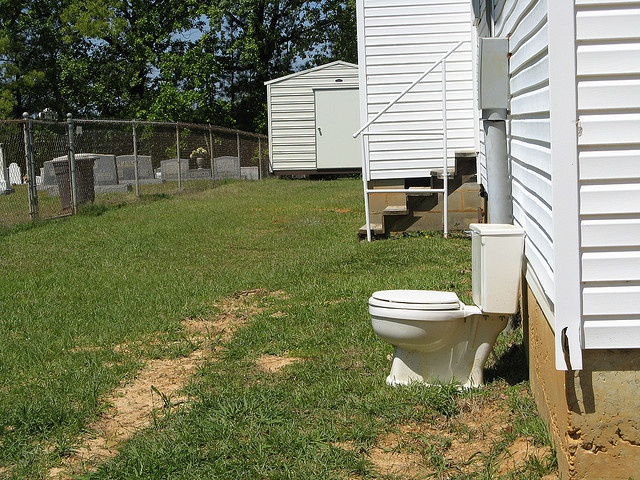Describe the objects in this image and their specific colors. I can see a toilet in darkgreen, lightgray, gray, olive, and darkgray tones in this image. 